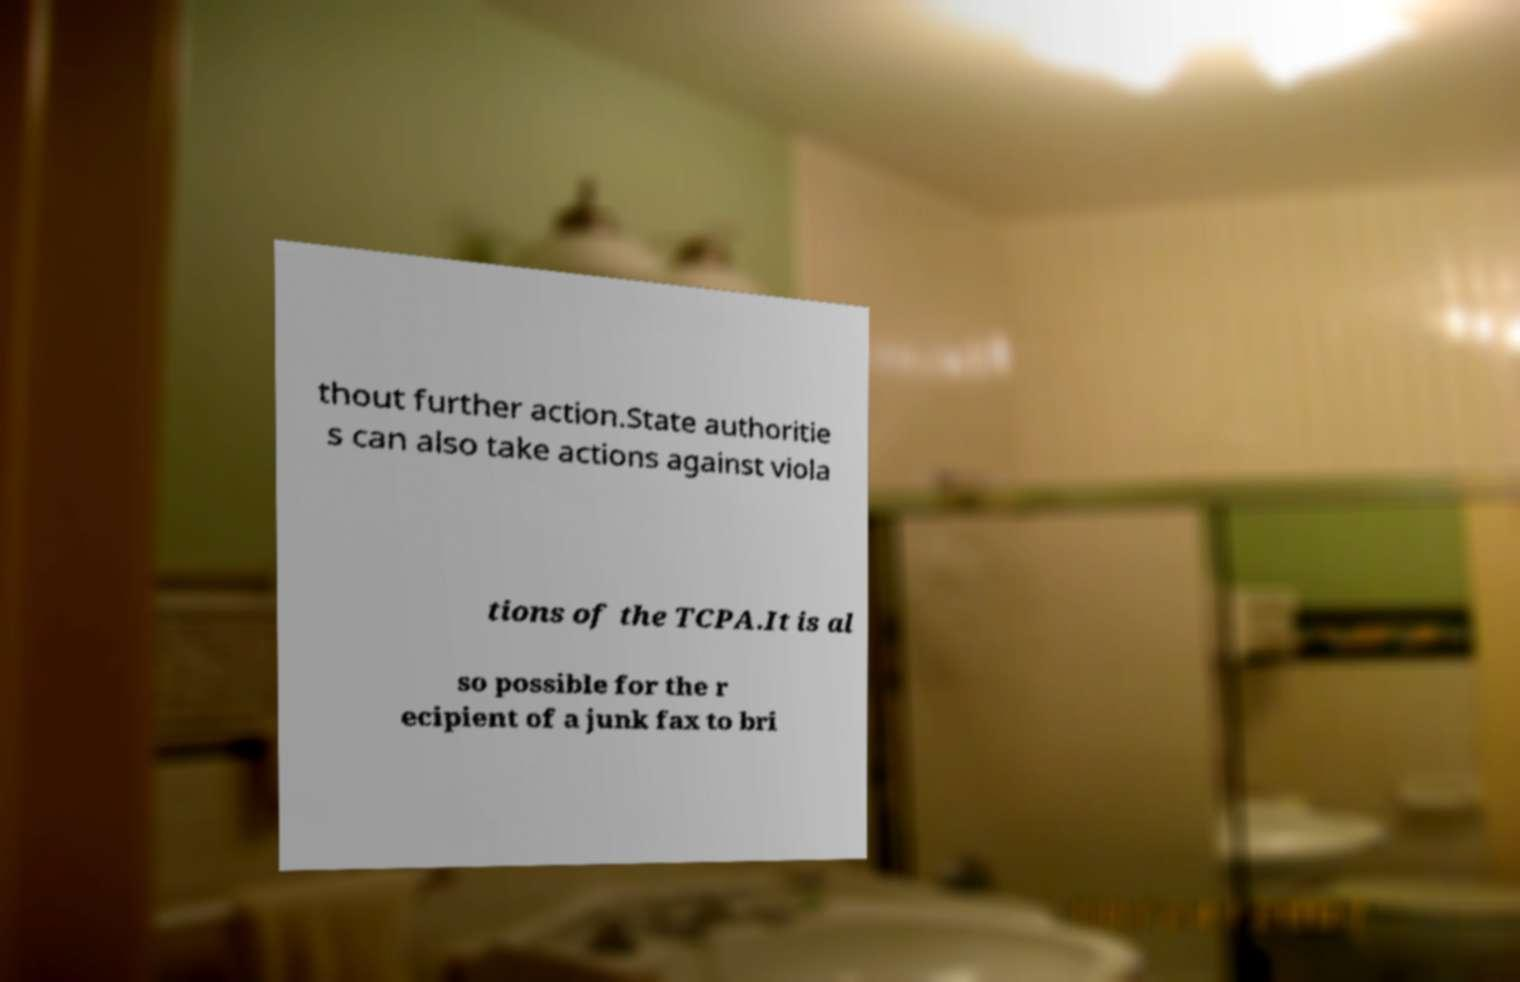For documentation purposes, I need the text within this image transcribed. Could you provide that? thout further action.State authoritie s can also take actions against viola tions of the TCPA.It is al so possible for the r ecipient of a junk fax to bri 